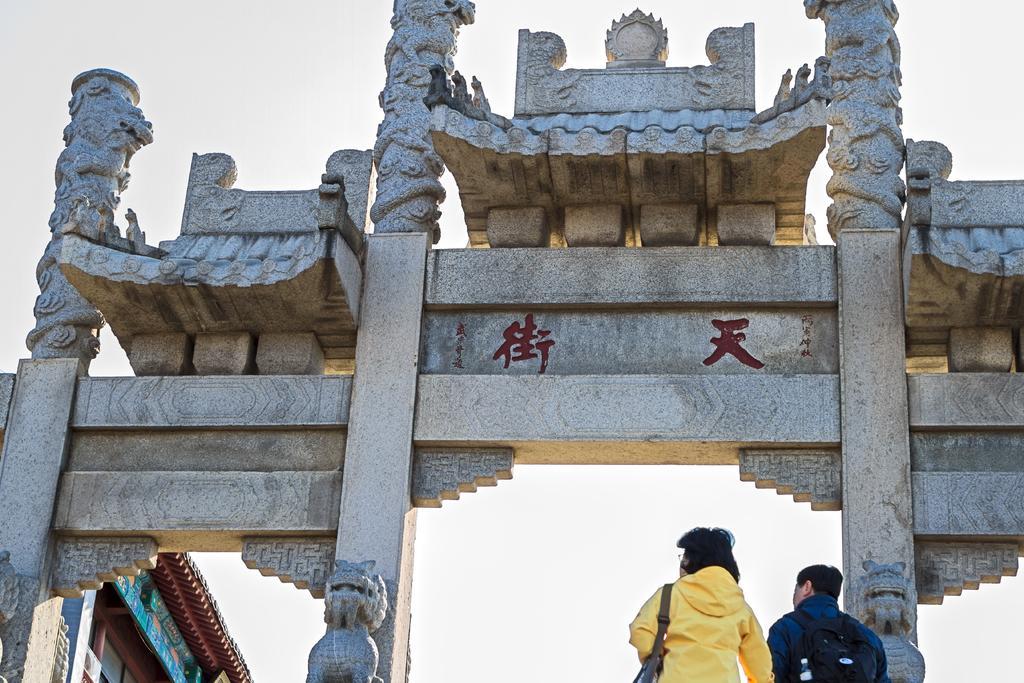Please provide a concise description of this image. In this picture I can see the arch in front and I can see sculptures and something is written on it. On the bottom of this picture I can see 2 persons who are standing and wearing bags. On the bottom left corner of this picture I can see a building. 